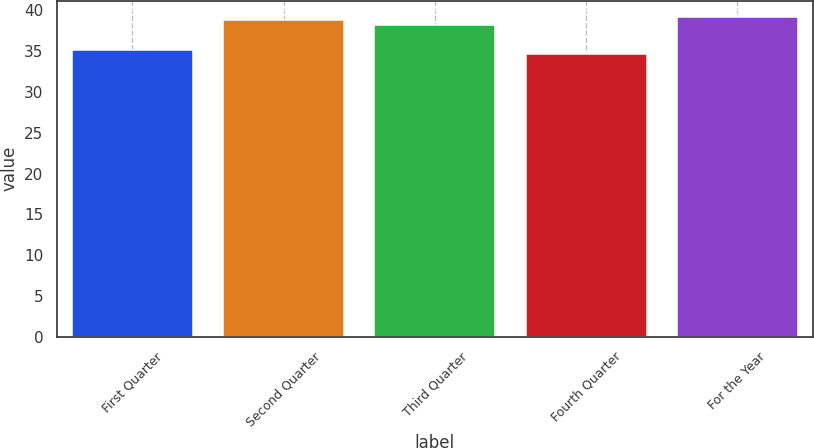Convert chart to OTSL. <chart><loc_0><loc_0><loc_500><loc_500><bar_chart><fcel>First Quarter<fcel>Second Quarter<fcel>Third Quarter<fcel>Fourth Quarter<fcel>For the Year<nl><fcel>35.2<fcel>38.84<fcel>38.2<fcel>34.72<fcel>39.25<nl></chart> 